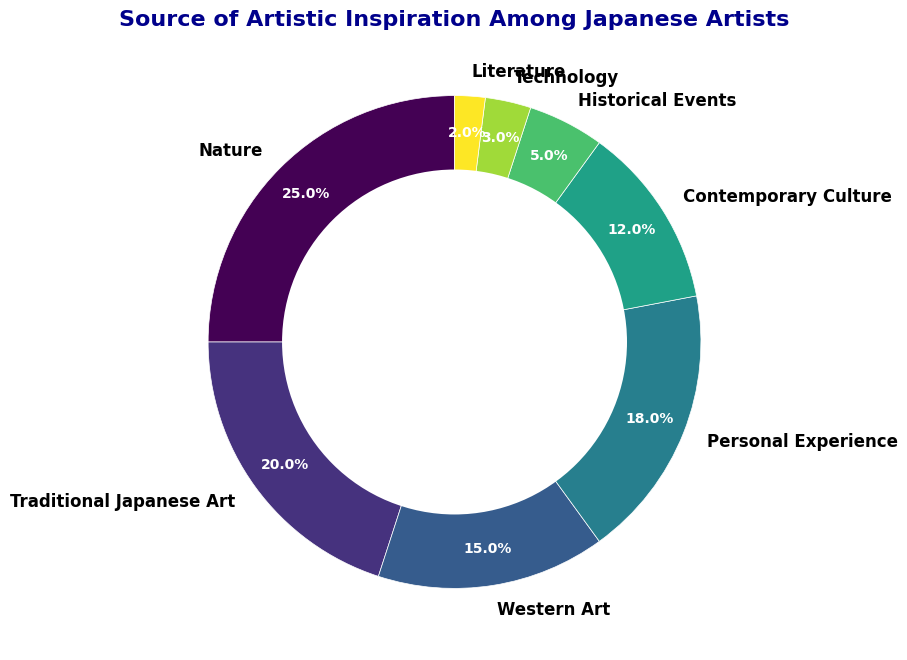What's the most common source of artistic inspiration among Japanese artists? The ring chart shows the slices corresponding to each inspiration source. The largest slice represents "Nature" with 25%.
Answer: Nature What percentage of artists draw inspiration from both Traditional Japanese Art and Western Art combined? To find this, add the percentages of "Traditional Japanese Art" (20%) and "Western Art" (15%). 20% + 15% = 35%.
Answer: 35% Which source of inspiration is less common: Contemporary Culture or Historical Events? By comparing the sizes of the respective slices, "Historical Events" is smaller at 5% compared to "Contemporary Culture" at 12%.
Answer: Historical Events How much more popular is Nature as an inspiration source compared to Technology? To find the difference in their percentages, subtract the percentage for "Technology" (3%) from "Nature" (25%). 25% - 3% = 22%.
Answer: 22% Which segment of the ring chart represents the least common source of artistic inspiration, and what is its percentage? Analyze the smallest slice in the ring chart, which corresponds to "Literature" with 2%.
Answer: Literature, 2% Are there more artists inspired by Personal Experience or by Contemporary Culture, and by how much? Compare the percentages: "Personal Experience" is 18%, and "Contemporary Culture" is 12%. The difference is 18% - 12% = 6%.
Answer: Personal Experience by 6% What is the combined percentage of artists inspired by sources related to art forms (Traditional Japanese Art and Western Art)? To find this, sum the percentages of "Traditional Japanese Art" (20%) and "Western Art" (15%). 20% + 15% = 35%.
Answer: 35% Which two inspiration sources, when combined, sum up to more than 30% but less than 40%? We need pairs of percentages summing to between 30% and 40%. "Traditional Japanese Art" (20%) and "Personal Experience" (18%) add up to 38%, falling in this range.
Answer: Traditional Japanese Art and Personal Experience What fraction of the ring chart is made up of inspiration sources with percentages less than 10%? Sum the percentages of "Historical Events" (5%), "Technology" (3%), and "Literature" (2%). 5% + 3% + 2% = 10%. Since the total is 100%, the fraction is 10/100 = 0.1 or 10%.
Answer: 10% What is the summed percentage of the three least common sources of inspiration? The least common sources are "Literature" (2%), "Technology" (3%), and "Historical Events" (5%). Sum these: 2% + 3% + 5% = 10%.
Answer: 10% 